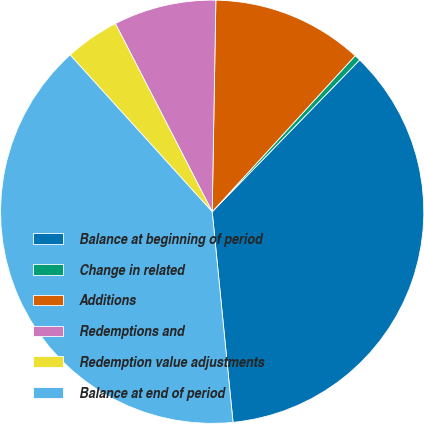Convert chart to OTSL. <chart><loc_0><loc_0><loc_500><loc_500><pie_chart><fcel>Balance at beginning of period<fcel>Change in related<fcel>Additions<fcel>Redemptions and<fcel>Redemption value adjustments<fcel>Balance at end of period<nl><fcel>36.16%<fcel>0.46%<fcel>11.53%<fcel>7.84%<fcel>4.15%<fcel>39.85%<nl></chart> 